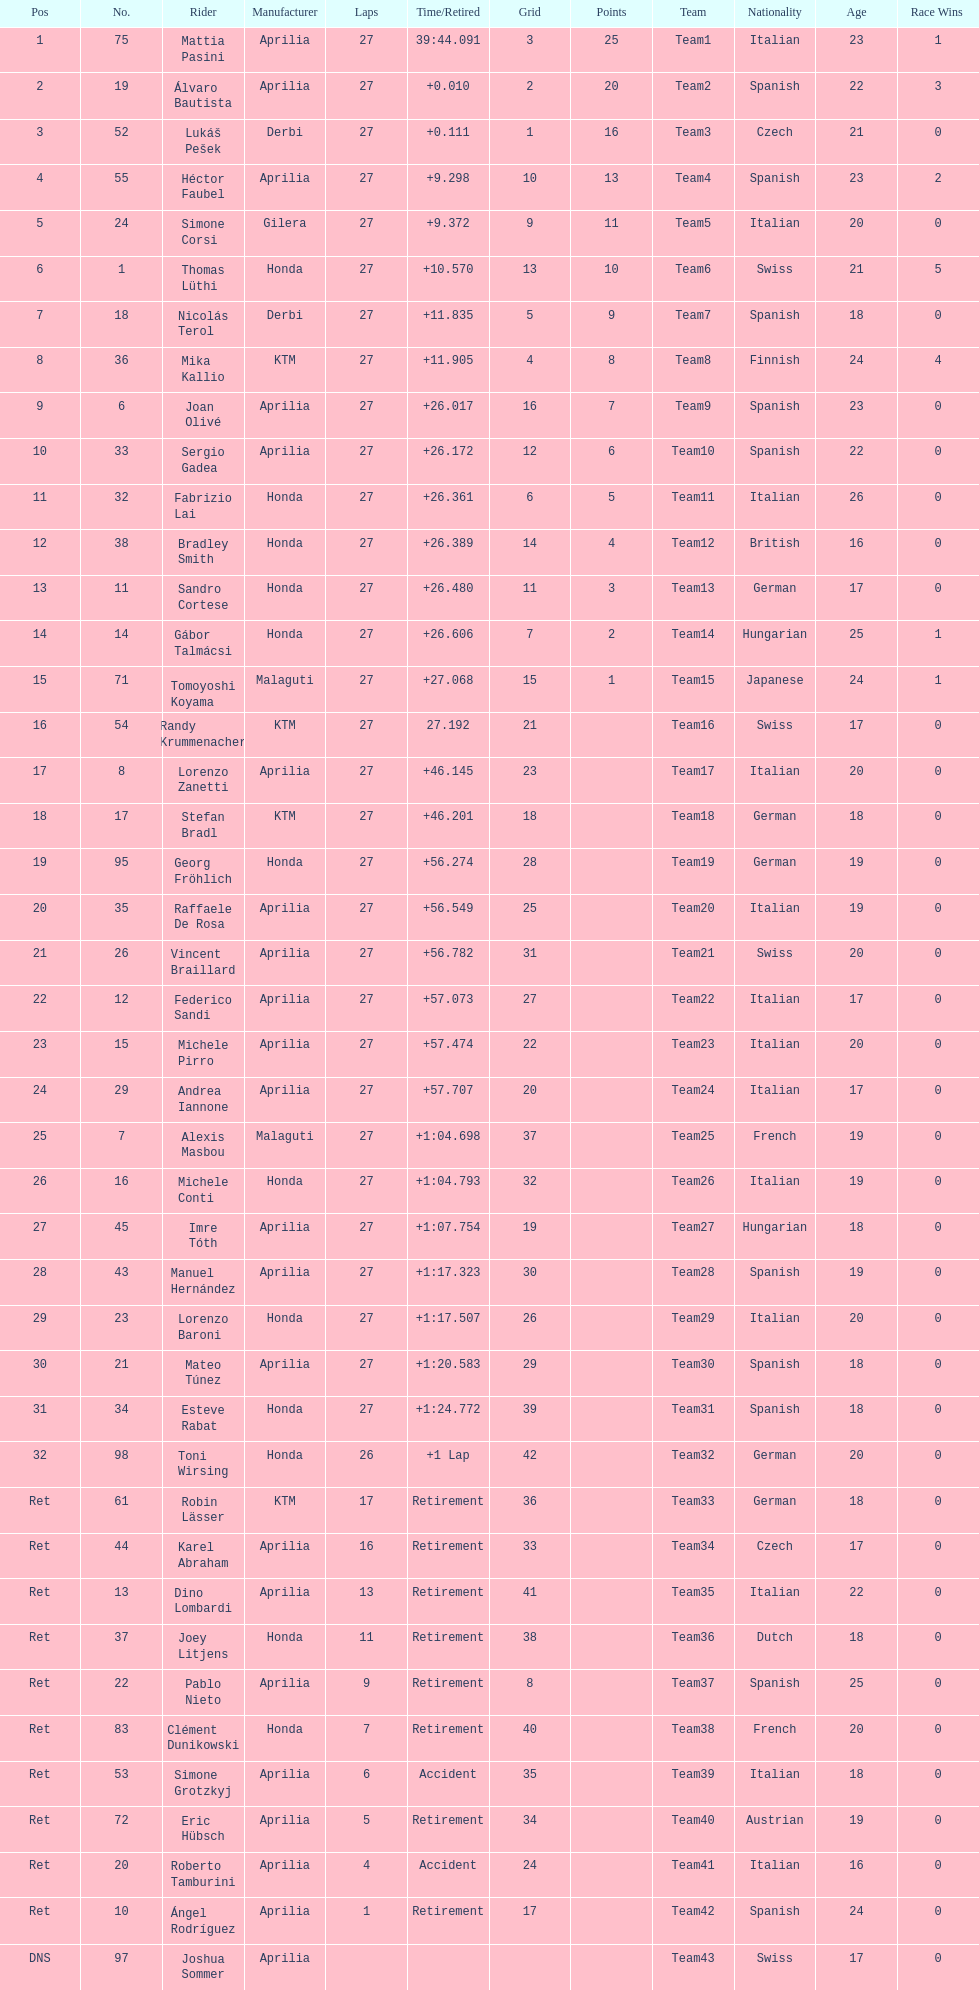Who placed higher, bradl or gadea? Sergio Gadea. 